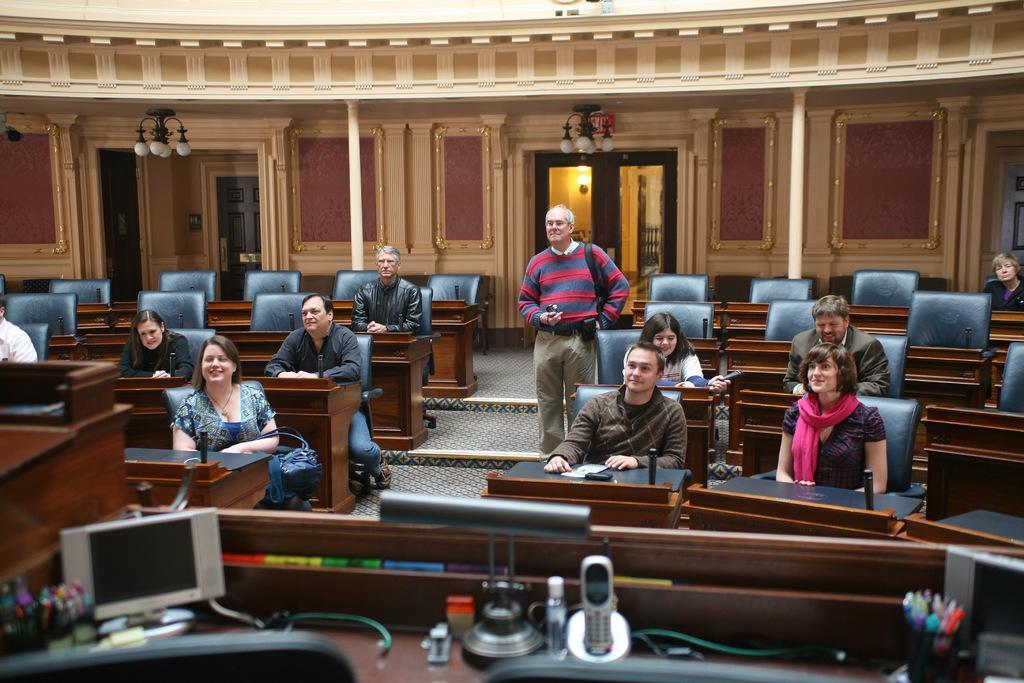Describe this image in one or two sentences. In this image in the front there is a table and on the table there are objects which are white and black in colour and there are pens in the pen stand. On the left side of the table there is a screen and in the center there are persons sitting and smiling and there is a man standing in the center and there are empty chairs. In the background there are chandeliers hanging and there are doors and there is a wall and there are pillars. 